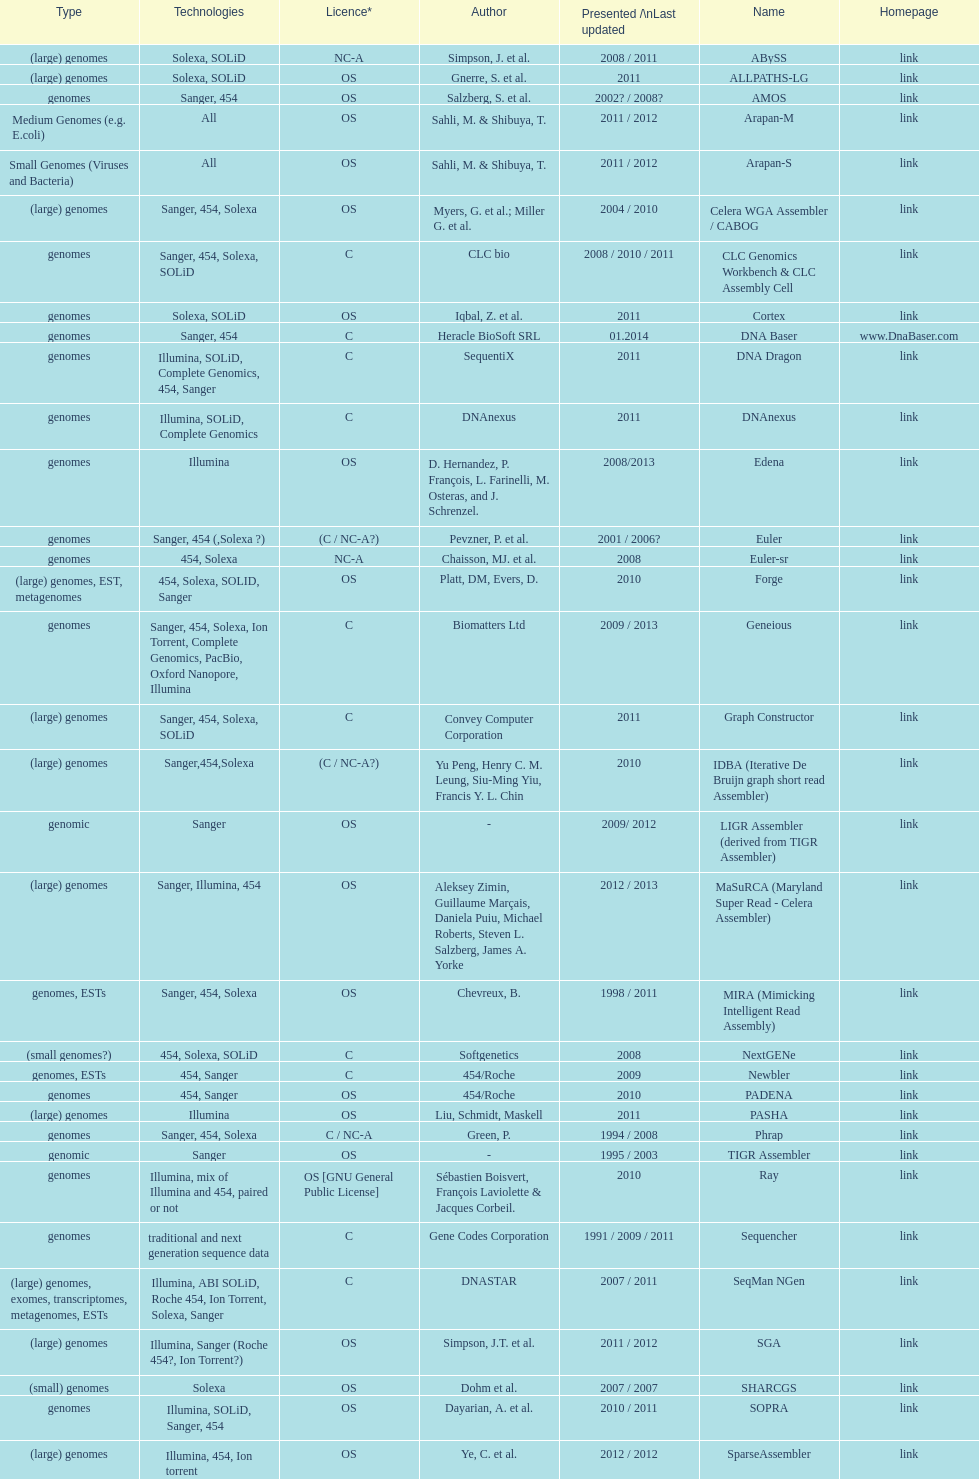Which license is listed more, os or c? OS. 